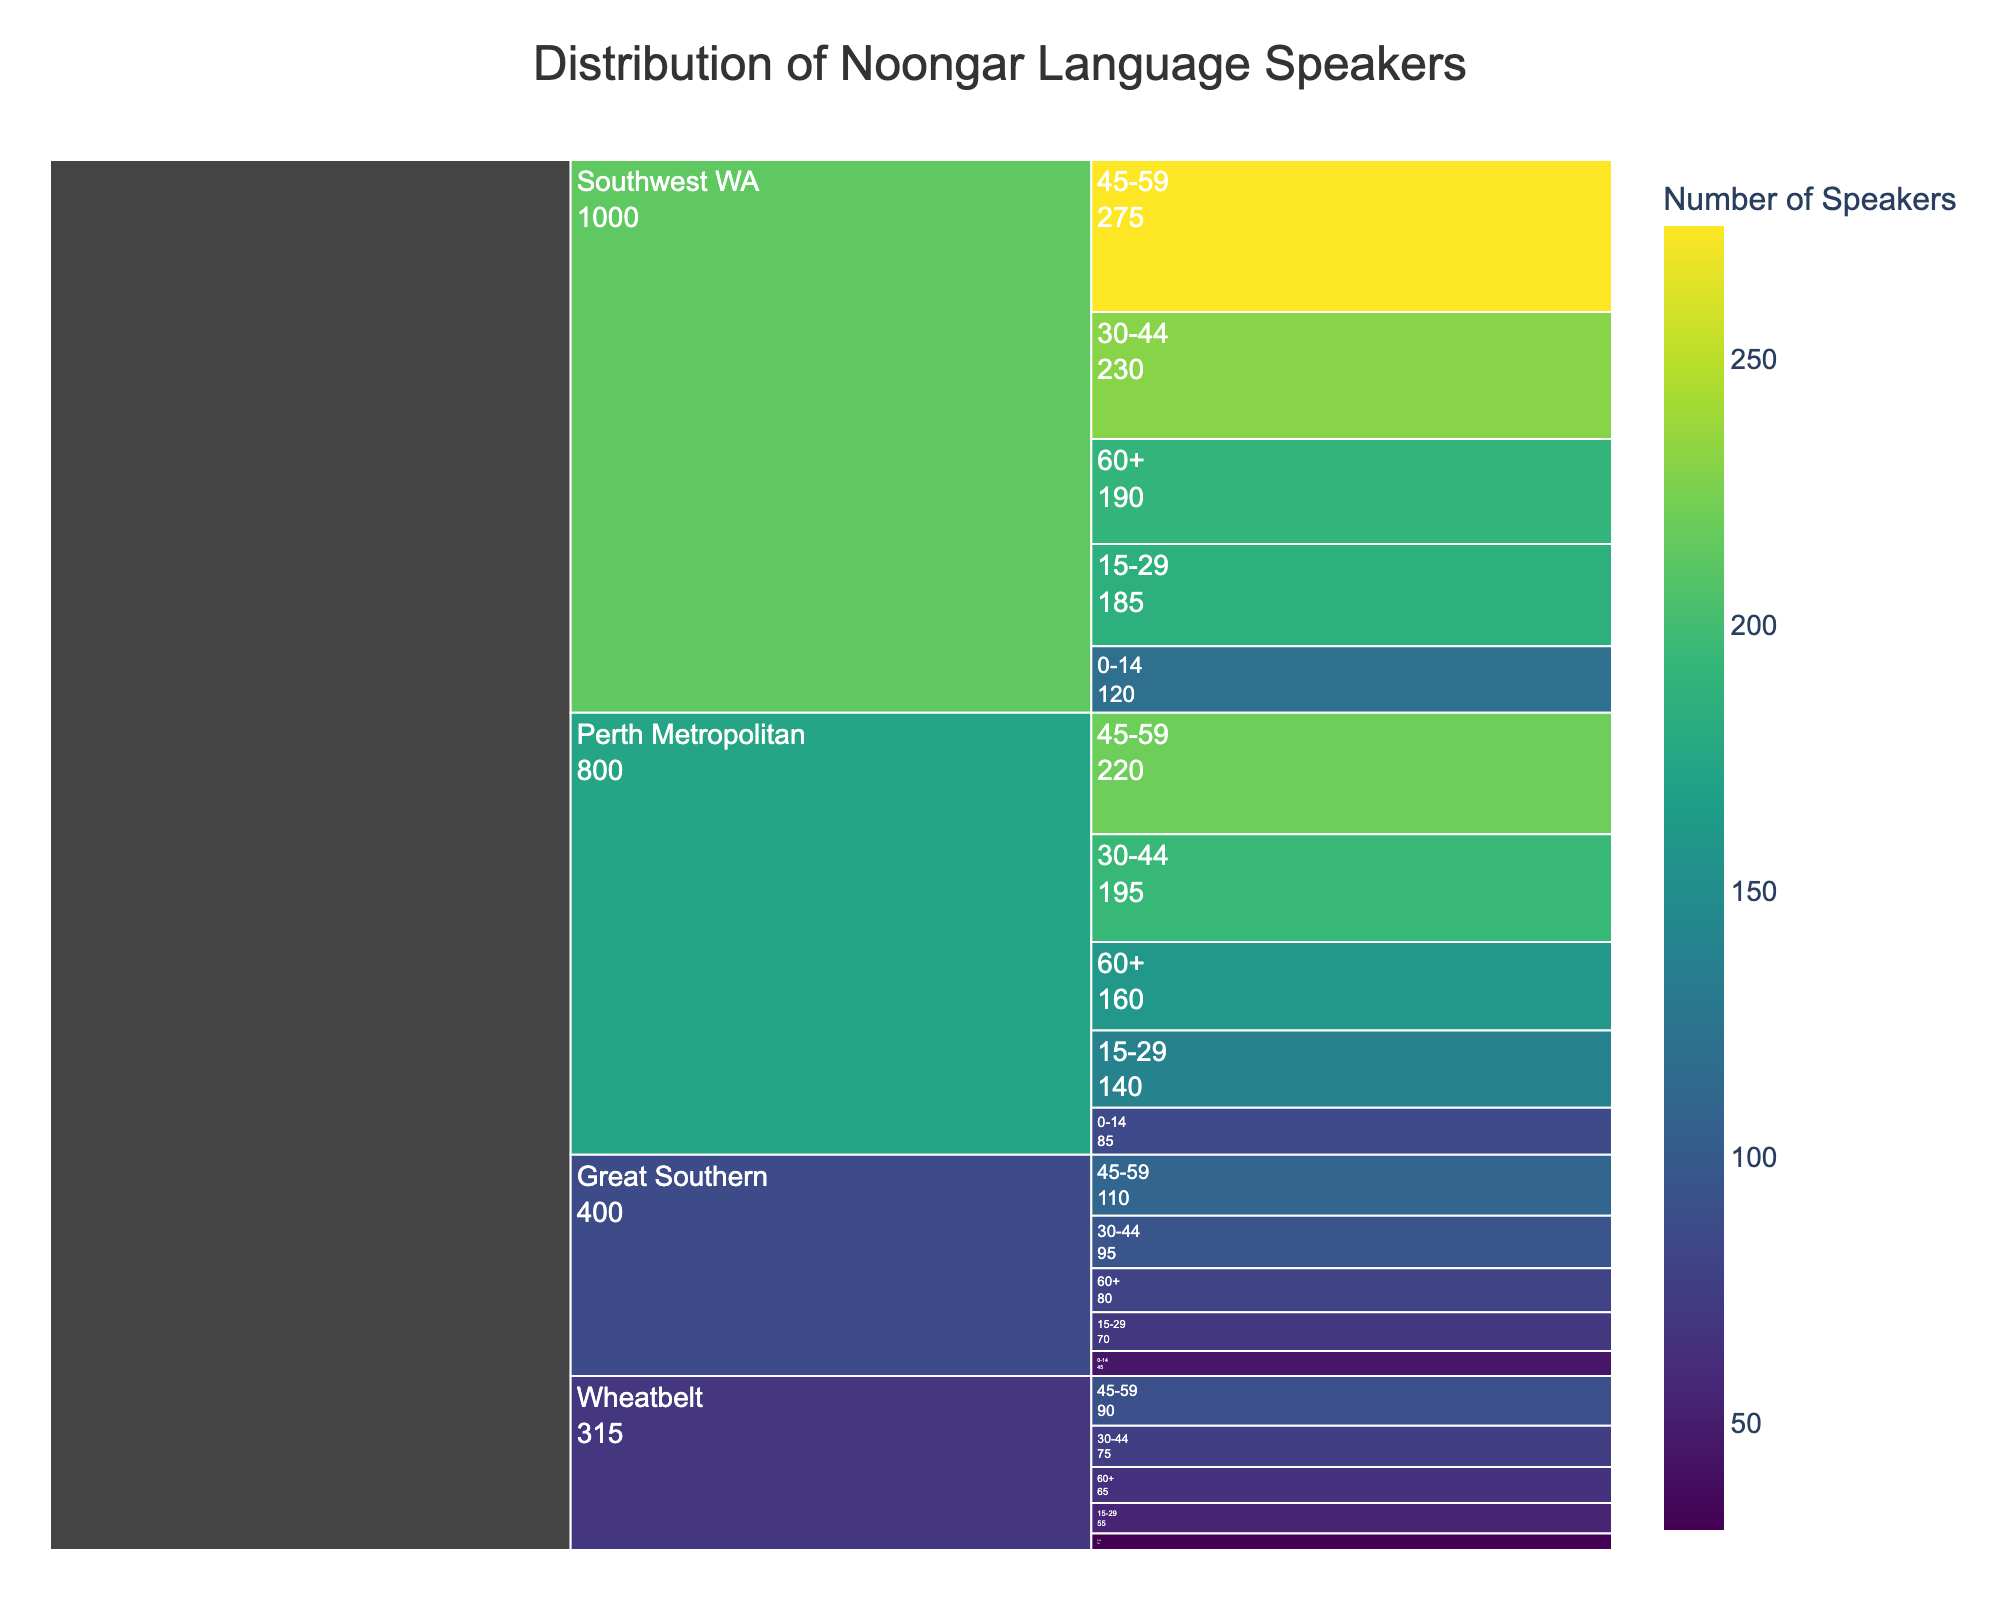What's the title of the figure? The title of the figure is displayed at the top and indicates what the figure represents.
Answer: Distribution of Noongar Language Speakers Which region has the highest number of speakers in the 45-59 age group? By looking at the section of the icicle chart corresponding to the 45-59 age group, compare the values for each region. The Southwest WA has the most speakers in this age group.
Answer: Southwest WA How many Noongar speakers are there in the Wheatbelt region for the 0-14 age group? Identify the segment for the Wheatbelt region and then locate the value for the 0-14 age group within this region. The number is directly shown.
Answer: 30 What is the total number of Noongar language speakers in the Great Southern region? Sum the number of speakers across all age groups within the Great Southern region.
Answer: 400 Which age group in the Perth Metropolitan region has the fewest number of Noongar language speakers? Compare the values for each age group in the Perth Metropolitan region and identify the smallest one. The 0-14 age group has the fewest speakers.
Answer: 0-14 What's the difference in the number of Noongar speakers between Southwest WA and Perth Metropolitan for the 60+ age group? Find the values of Noongar speakers in the 60+ age group for both regions and subtract the smaller number from the larger one: 190 (Southwest WA) - 160 (Perth Metropolitan).
Answer: 30 Which age group generally has the most Noongar language speakers across all regions? By examining the values for each age group across all regions and comparing them, the 45-59 age group has the most number of speakers across all regions.
Answer: 45-59 What is the combined total number of Noongar language speakers aged 30-44 in Southwest WA and Perth Metropolitan? Sum the number of speakers in the 30-44 age group for both Southwest WA and Perth Metropolitan regions: 230 (Southwest WA) + 195 (Perth Metropolitan).
Answer: 425 Which region has the least representation of the 15-29 age group? Compare the values for the 15-29 age group across all regions and identify the smallest number. The Wheatbelt has the least representation in this age group.
Answer: Wheatbelt In terms of Noongar language speakers, how does the Great Southern region's 45-59 age group compare with the Wheatbelt's 30-44 age group? Compare the number of speakers in the Great Southern region's 45-59 age group (110) with the Wheatbelt's 30-44 age group (75). Great Southern's 45-59 age group is larger.
Answer: Greater 